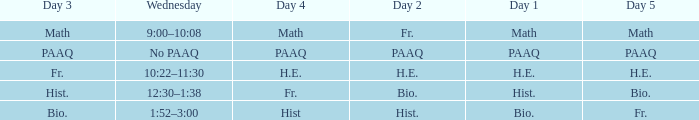What is the Wednesday when day 3 is math? 9:00–10:08. 